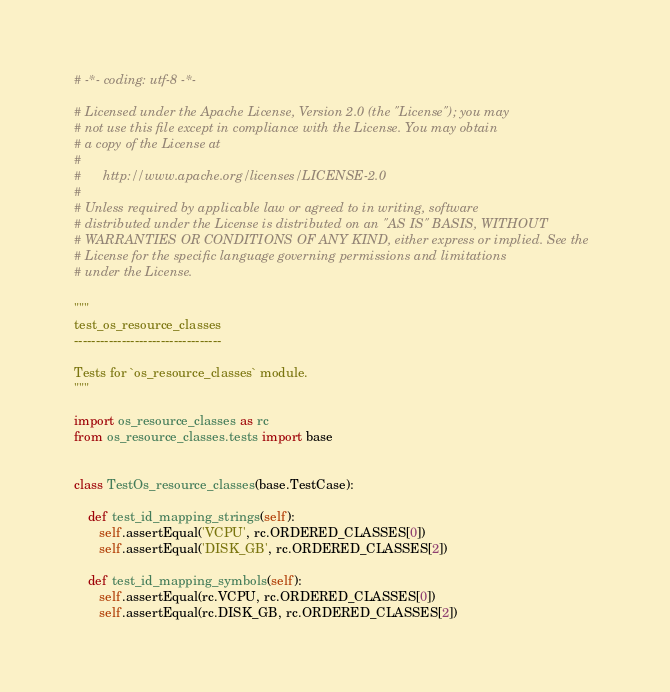Convert code to text. <code><loc_0><loc_0><loc_500><loc_500><_Python_># -*- coding: utf-8 -*-

# Licensed under the Apache License, Version 2.0 (the "License"); you may
# not use this file except in compliance with the License. You may obtain
# a copy of the License at
#
#      http://www.apache.org/licenses/LICENSE-2.0
#
# Unless required by applicable law or agreed to in writing, software
# distributed under the License is distributed on an "AS IS" BASIS, WITHOUT
# WARRANTIES OR CONDITIONS OF ANY KIND, either express or implied. See the
# License for the specific language governing permissions and limitations
# under the License.

"""
test_os_resource_classes
----------------------------------

Tests for `os_resource_classes` module.
"""

import os_resource_classes as rc
from os_resource_classes.tests import base


class TestOs_resource_classes(base.TestCase):

    def test_id_mapping_strings(self):
       self.assertEqual('VCPU', rc.ORDERED_CLASSES[0])
       self.assertEqual('DISK_GB', rc.ORDERED_CLASSES[2])

    def test_id_mapping_symbols(self):
       self.assertEqual(rc.VCPU, rc.ORDERED_CLASSES[0])
       self.assertEqual(rc.DISK_GB, rc.ORDERED_CLASSES[2])
</code> 